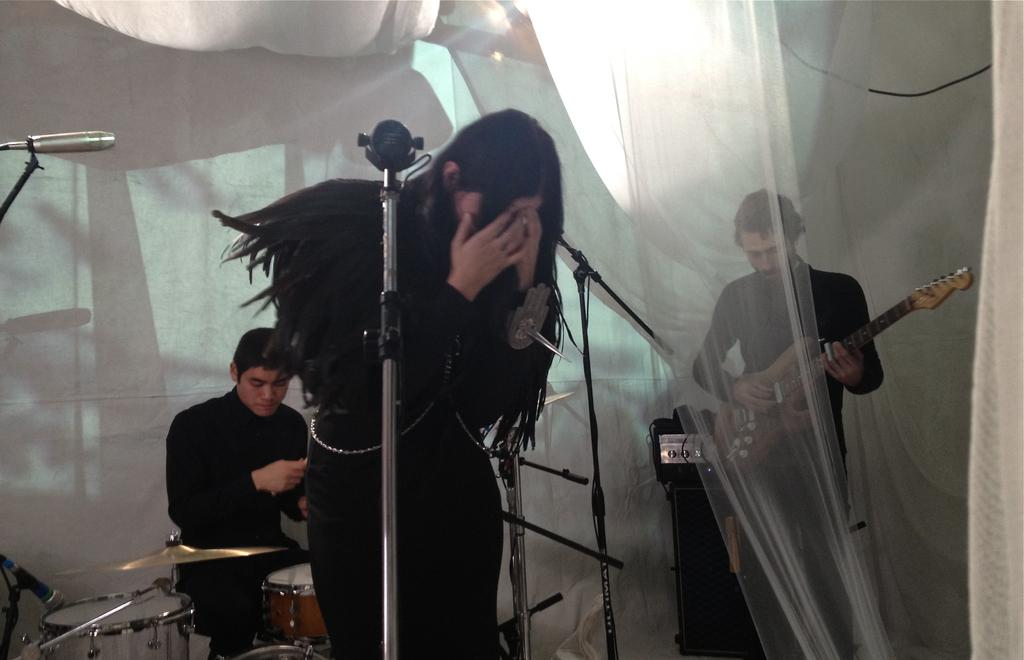What is the man in the image doing? The man is playing a guitar and drums in the image. Who else is present in the image? There is a woman standing in front of a microphone. What can be seen in the background of the image? The background is decorated with a white cloth. What type of calculator is the woman using while singing in the image? There is no calculator present in the image; the woman is standing in front of a microphone. What color are the stockings worn by the man while playing the guitar and drums in the image? There is no mention of stockings in the image, as the focus is on the instruments being played. 